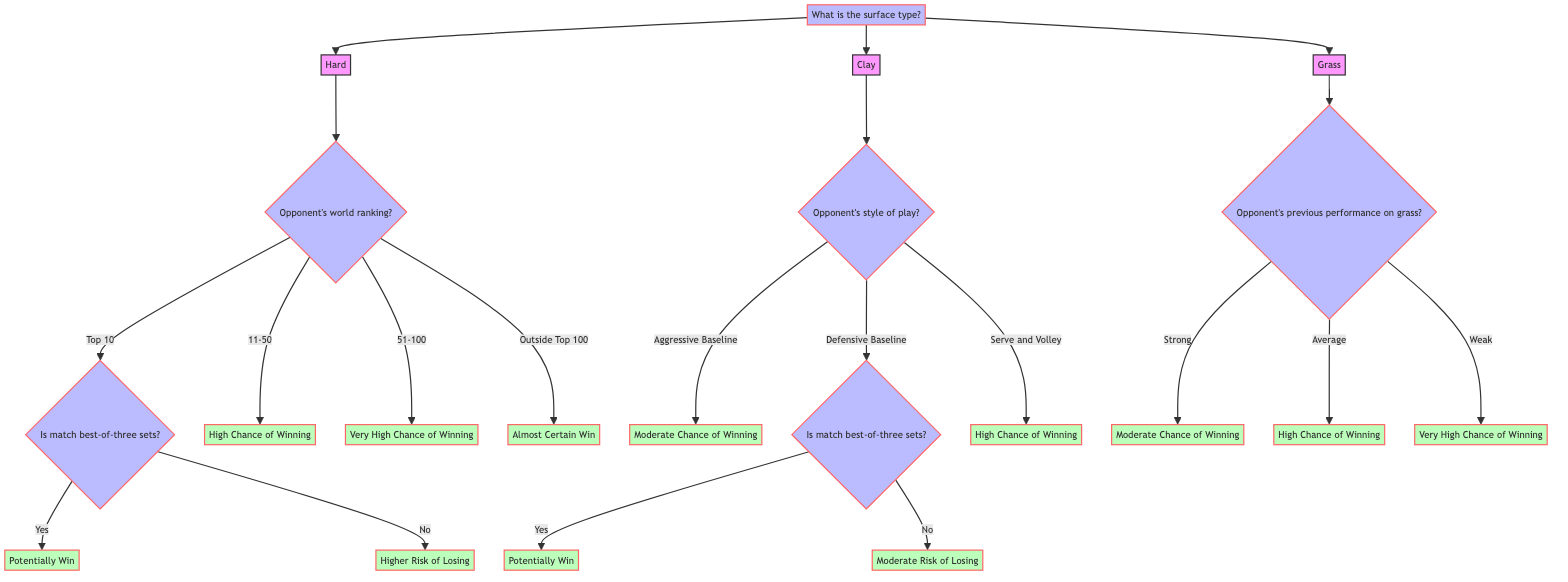What is the first question in the diagram? The first question in the diagram is found at the root node. It asks, "What is the surface type?"
Answer: What is the surface type? How many different surface types are considered in the diagram? The diagram considers three surface types: Hard, Clay, and Grass. This is evident from the first branching of the tree.
Answer: Three If the surface type is Clay and the opponent’s style of play is Serve and Volley, what is the outcome? Following the paths for Clay, the outcome for a Serve and Volley opponent is "High Chance of Winning." This is indicated directly from that specific branch.
Answer: High Chance of Winning What happens if the surface type is Hard and the opponent is ranked outside the Top 100? For Hard surface, if the opponent is ranked outside the Top 100, the outcome is "Almost Certain Win," as per the third bin under ranking.
Answer: Almost Certain Win What is the outcome if the opponent is a Defensive Baseline player on Clay and the match is not best-of-three sets? If the opponent is a Defensive Baseline player and the match is not best-of-three sets, the outcome is "Moderate Risk of Losing." This conclusion is reached by following the relevant branches in the decision tree.
Answer: Moderate Risk of Losing If Ashleigh Barty plays against a Top 10 opponent on Hard surface and the match is best-of-three sets, what is the prediction? The prediction in this case would be "Potentially Win," based on the flow starting from Hard surface, going to Top 10 ranking, and confirming the set format.
Answer: Potentially Win What is the last decision point for outcomes related to Grass surface? The last decision point concerning Grass requires analyzing the opponent's previous performance on grass, which leads to three outcomes: Strong, Average, or Weak. This indicates that their performance directly influences the subsequent outcomes.
Answer: Opponent's previous performance on grass What indicates a higher risk in the match on Hard surface? A higher risk in a match occurs if the opponent is ranked in the Top 10 and it is not a best-of-three sets match, leading to the outcome "Higher Risk of Losing."
Answer: Higher Risk of Losing In the case of an aggressive baseline opponent on Clay, what is the outcome? The outcome for an aggressive baseline opponent on Clay is "Moderate Chance of Winning," indicating that this style presents a challenge for Ashleigh Barty.
Answer: Moderate Chance of Winning 